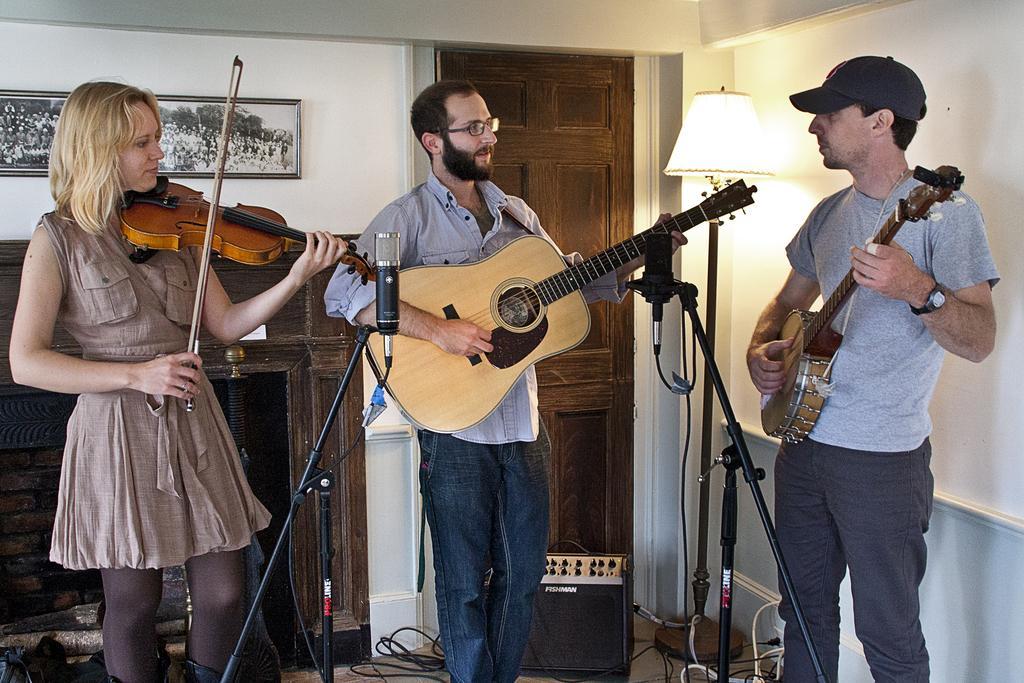Could you give a brief overview of what you see in this image? This image is clicked inside a room. In this image, there are three persons. To the left, there is woman wearing brown dress and playing violin. To the right, the man wearing cap and watch. In the middle,the man is wearing gray shirt is playing guitar. In the background there is a door, wall and photo frame. 